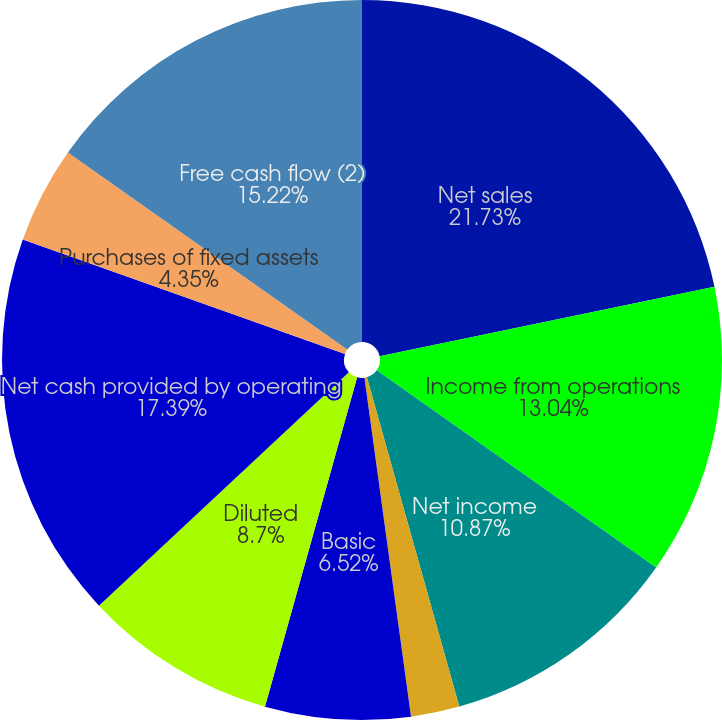Convert chart to OTSL. <chart><loc_0><loc_0><loc_500><loc_500><pie_chart><fcel>Net sales<fcel>Income from operations<fcel>Net income<fcel>Basic earnings per share (1)<fcel>Diluted earnings per share (1)<fcel>Basic<fcel>Diluted<fcel>Net cash provided by operating<fcel>Purchases of fixed assets<fcel>Free cash flow (2)<nl><fcel>21.74%<fcel>13.04%<fcel>10.87%<fcel>2.18%<fcel>0.0%<fcel>6.52%<fcel>8.7%<fcel>17.39%<fcel>4.35%<fcel>15.22%<nl></chart> 